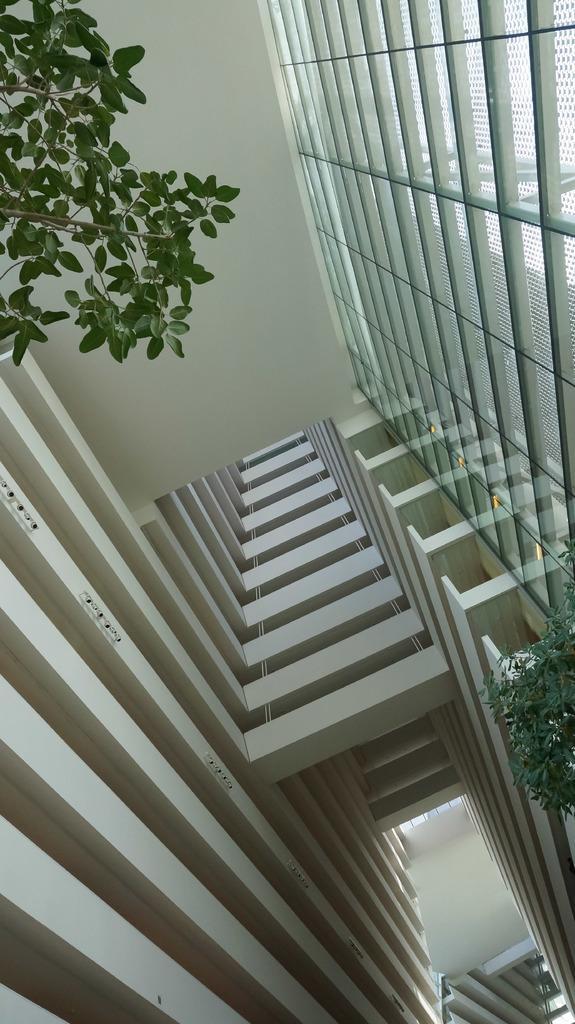In one or two sentences, can you explain what this image depicts? In this picture I can see the inside view of a building and I see number of leaves on both sides of this image and on the right top of this picture I can see the glass wall. 